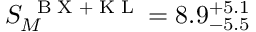Convert formula to latex. <formula><loc_0><loc_0><loc_500><loc_500>S _ { M } ^ { B X + K L } = 8 . 9 _ { - 5 . 5 } ^ { + 5 . 1 }</formula> 